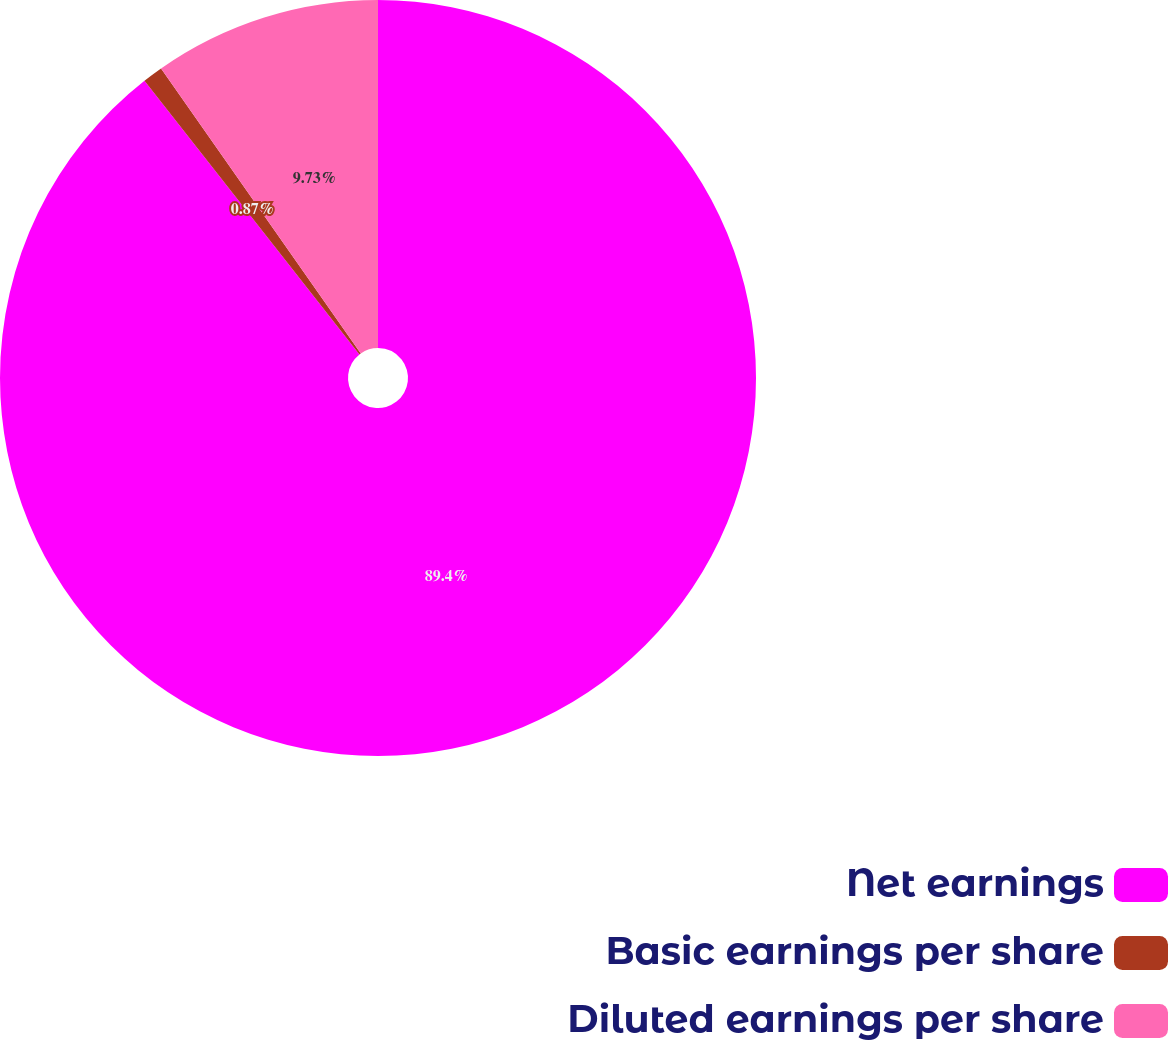Convert chart. <chart><loc_0><loc_0><loc_500><loc_500><pie_chart><fcel>Net earnings<fcel>Basic earnings per share<fcel>Diluted earnings per share<nl><fcel>89.41%<fcel>0.87%<fcel>9.73%<nl></chart> 